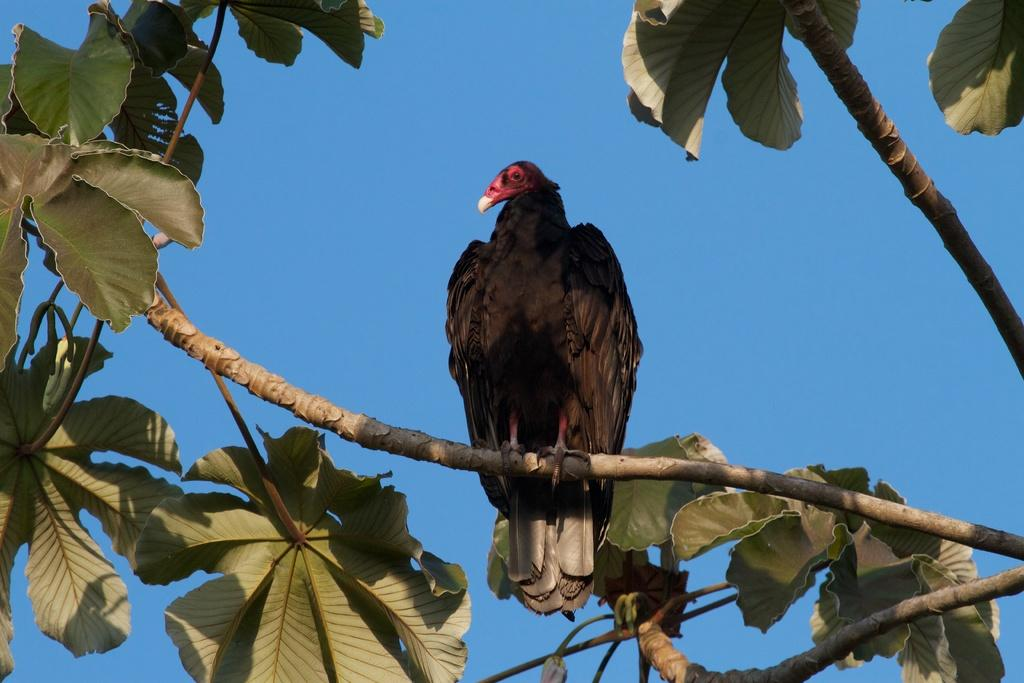What type of animal is present in the image? There is a bird in the image. Where is the bird located in the image? The bird is on a tree branch. What type of vegetation is visible in the image? There are leaves visible in the image. What color is the sky in the image? The sky is blue in the image. What type of milk is the bird drinking from a sail in the image? There is no milk, sail, or any activity involving drinking milk in the image. The bird is simply perched on a tree branch. 